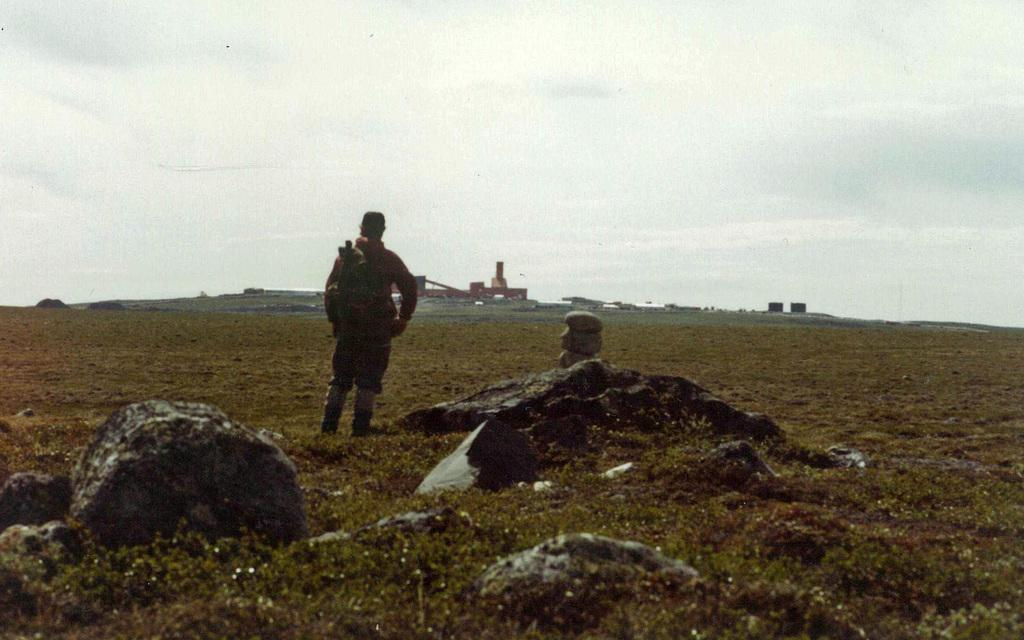What type of vegetation covers the land in the image? The land is filled with grass. Can you describe the person standing on the land? There is a man standing on the land, and he is facing away from the camera. What can be seen in the background of the image? The sky is visible in the background. What type of tin can be seen on the man's toe in the image? There is no tin or any object on the man's toe in the image. What kind of loaf is the man holding in the image? The man is not holding any loaf in the image. 